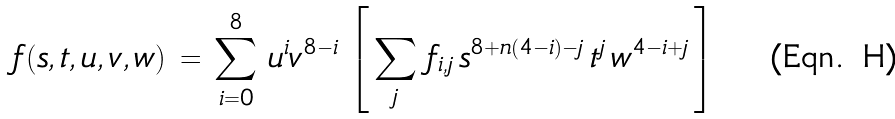Convert formula to latex. <formula><loc_0><loc_0><loc_500><loc_500>f ( s , t , u , v , w ) \, = \, \sum _ { i = 0 } ^ { 8 } \, u ^ { i } v ^ { 8 - i } \, \left [ \, \sum _ { j } \, f _ { i , j } \, s ^ { 8 + n ( 4 - i ) - j } \, t ^ { j } \, w ^ { 4 - i + j } \, \right ]</formula> 